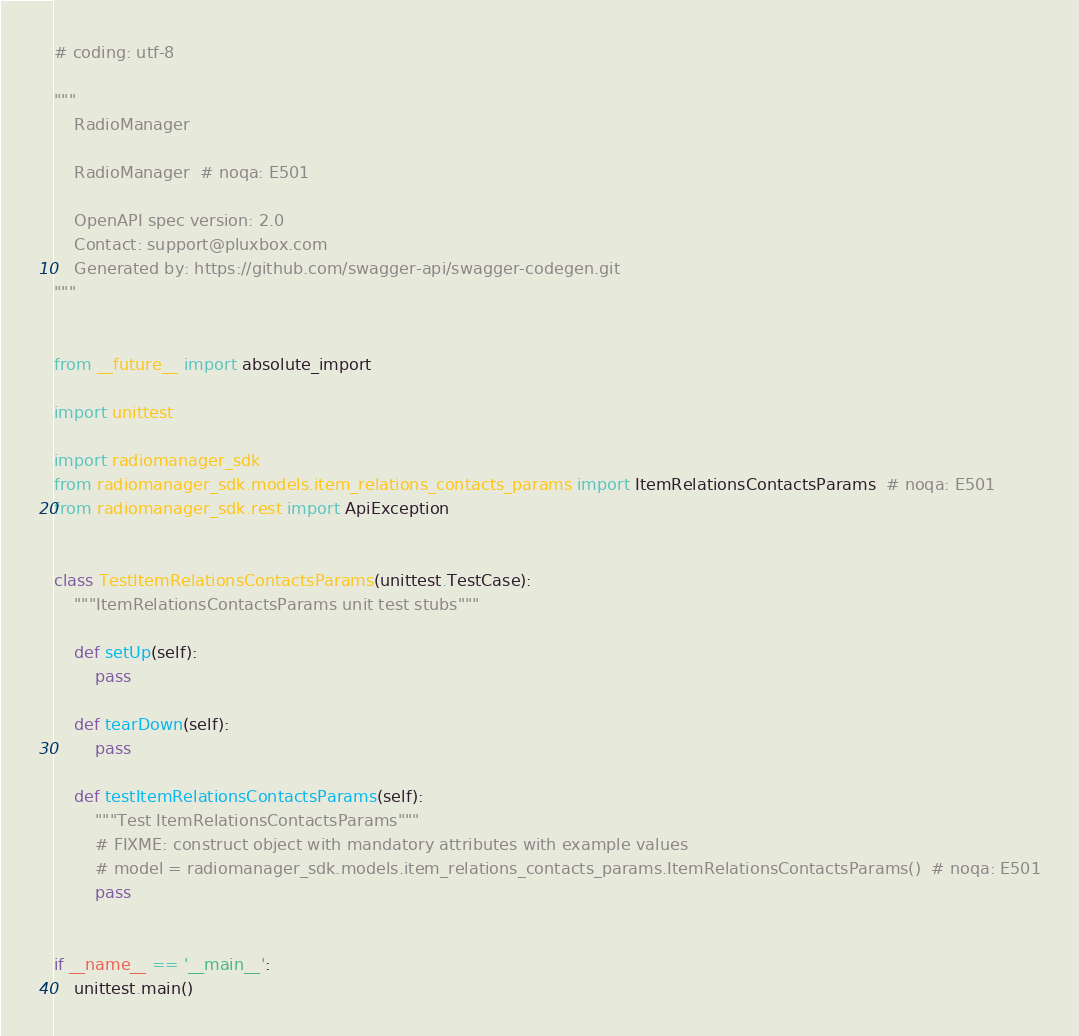<code> <loc_0><loc_0><loc_500><loc_500><_Python_># coding: utf-8

"""
    RadioManager

    RadioManager  # noqa: E501

    OpenAPI spec version: 2.0
    Contact: support@pluxbox.com
    Generated by: https://github.com/swagger-api/swagger-codegen.git
"""


from __future__ import absolute_import

import unittest

import radiomanager_sdk
from radiomanager_sdk.models.item_relations_contacts_params import ItemRelationsContactsParams  # noqa: E501
from radiomanager_sdk.rest import ApiException


class TestItemRelationsContactsParams(unittest.TestCase):
    """ItemRelationsContactsParams unit test stubs"""

    def setUp(self):
        pass

    def tearDown(self):
        pass

    def testItemRelationsContactsParams(self):
        """Test ItemRelationsContactsParams"""
        # FIXME: construct object with mandatory attributes with example values
        # model = radiomanager_sdk.models.item_relations_contacts_params.ItemRelationsContactsParams()  # noqa: E501
        pass


if __name__ == '__main__':
    unittest.main()
</code> 